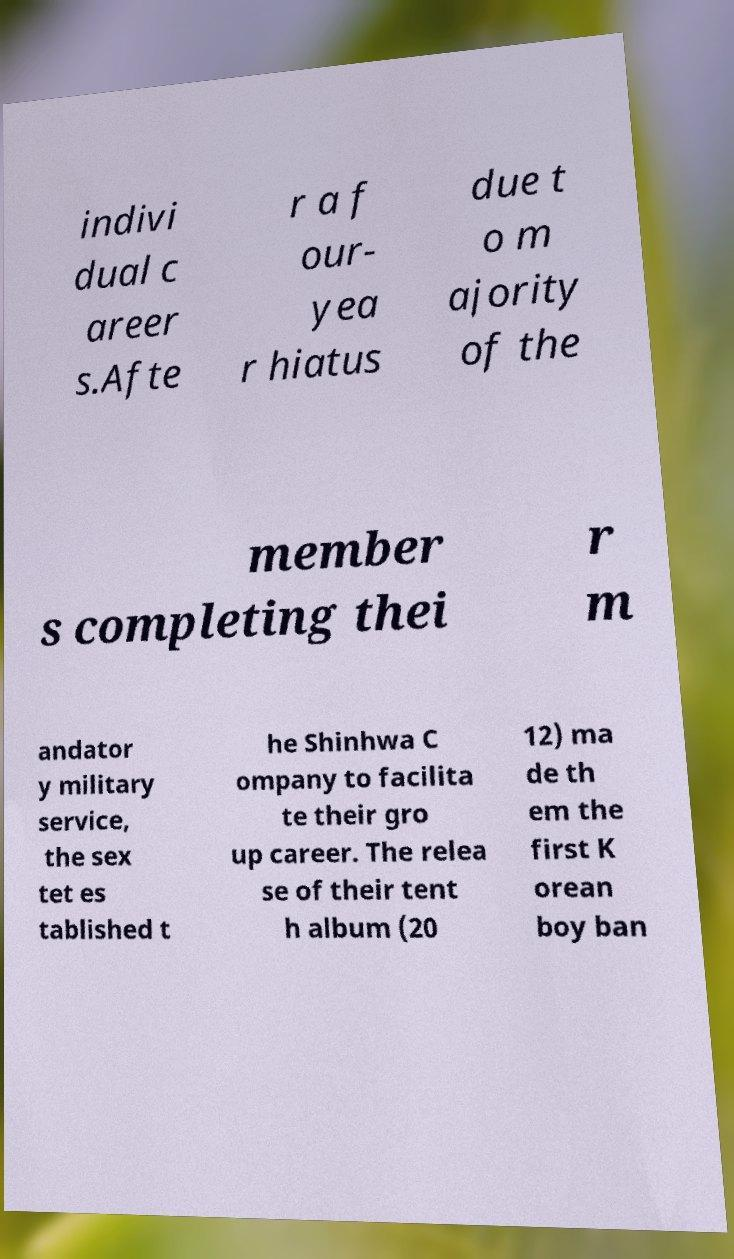Please identify and transcribe the text found in this image. indivi dual c areer s.Afte r a f our- yea r hiatus due t o m ajority of the member s completing thei r m andator y military service, the sex tet es tablished t he Shinhwa C ompany to facilita te their gro up career. The relea se of their tent h album (20 12) ma de th em the first K orean boy ban 